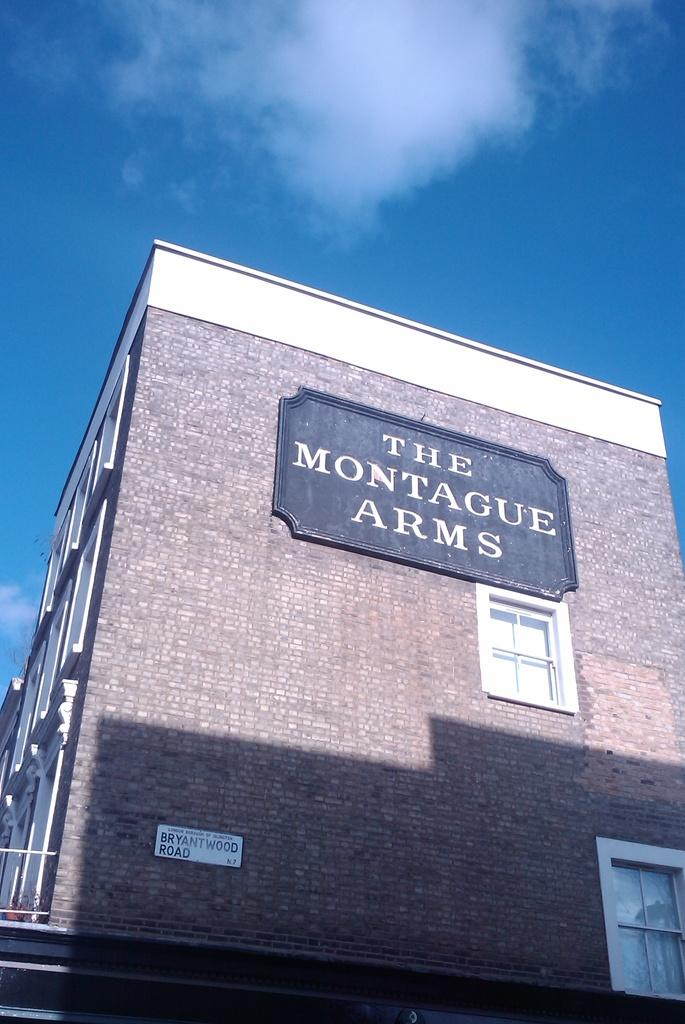What is the main subject in the center of the image? There is a temple in the center of the image. What can be seen in the background of the image? Sky is visible in the background of the image. What is the condition of the sky in the image? There are clouds in the sky. What type of paint is being used by the animal in the image? There is no animal present in the image, and therefore no paint or painting activity can be observed. 